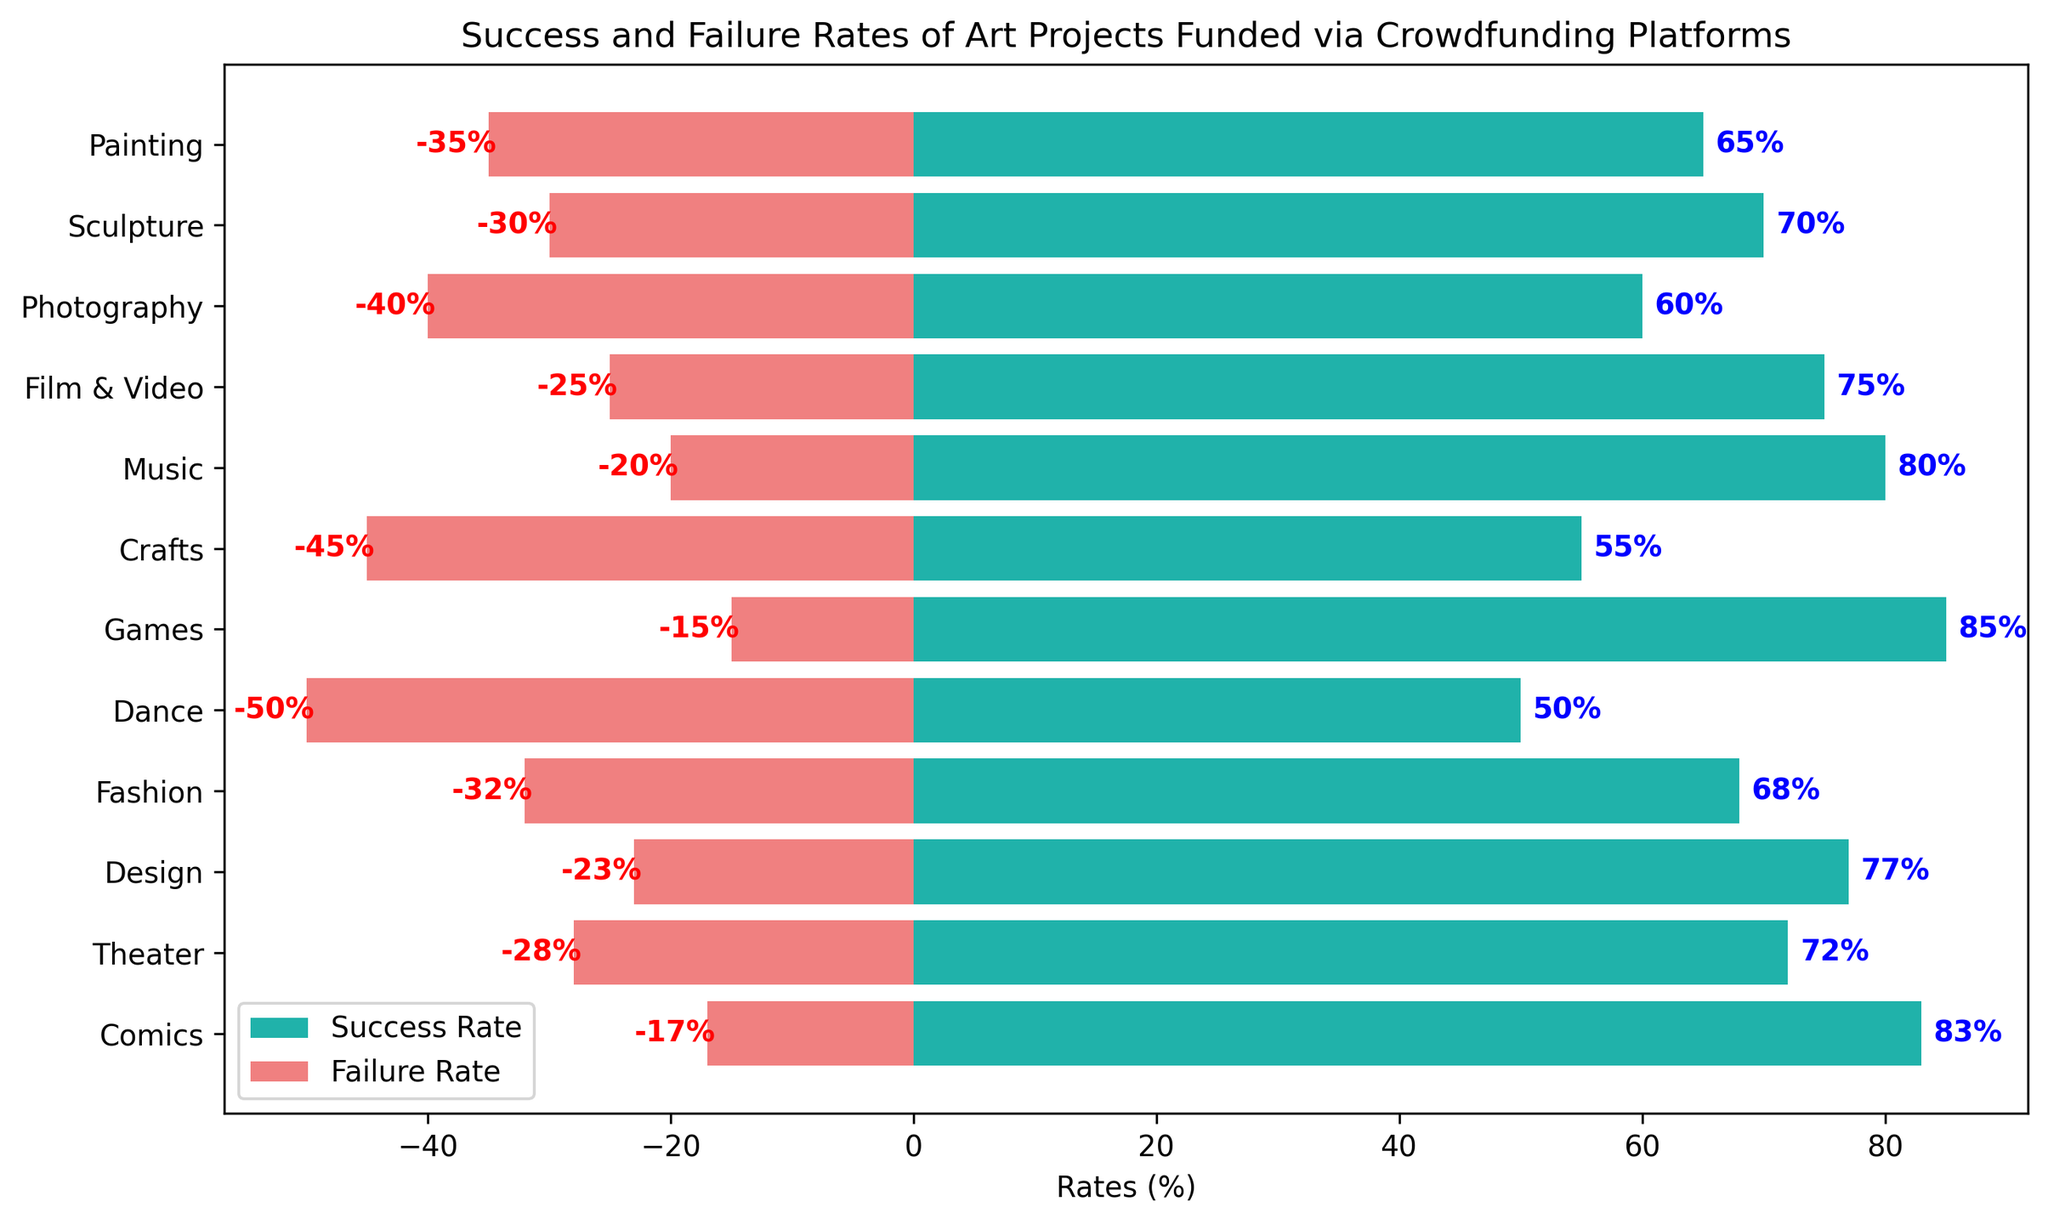What is the success rate for Painting projects? Look at the bar labeled 'Painting' on the y-axis and read the value of the corresponding lightseagreen bar.
Answer: 65% Which project category has the highest failure rate? Locate the longest red bar and check the corresponding category label on the y-axis.
Answer: Dance Compare the success rates between Music and Games projects. Which one is higher and by how much? Identify the lightseagreen bars for Music and Games. Music has 80%, and Games has 85%. Subtract the values: 85% - 80% = 5%.
Answer: Games by 5% What is the combined success rate of Film & Video and Fashion projects? Find the success rates of Film & Video (75%) and Fashion (68%). Add the values together: 75% + 68% = 143%.
Answer: 143% Which two categories have the most similar success rates? Compare the lengths of the lightseagreen bars to find the two that are closest in value. Painting (65%) and Photography (60%) are close, but Design (77%) and Theater (72%) are more similar.
Answer: Design and Theater Are there any project categories with the same failure rate? Check the lengths of the red bars to find any matches. There are no categories with the exact same failure rate.
Answer: No Which project category has the most balanced success and failure rates? Look for the categories with bars that are nearly equal in length but opposite in direction. The 'Dance' category has 50% success and -50% failure, so the total balance is 0%.
Answer: Dance Calculate the average success rate across all project categories. Add all success rates: 65 + 70 + 60 + 75 + 80 + 55 + 85 + 50 + 68 + 77 + 72 + 83. Divide by the number of categories, which is 12. Thus, the average is (65 + 70 + 60 + 75 + 80 + 55 + 85 + 50 + 68 + 77 + 72 + 83) / 12 = 70.42%.
Answer: 70.42% Identify the project category with the lowest success rate and state the percentage. Find the shortest lightseagreen bar and read the corresponding category label on the y-axis. The 'Dance' category has the lowest success rate of 50%.
Answer: Dance with 50% If we consider a project successful if its success rate is above 70%, how many categories fall into this range? Count the categories with lightseagreen bars extending beyond the 70% mark. These are: 'Film & Video' (75%), 'Music' (80%), 'Games' (85%), 'Design' (77%), 'Theater' (72%), and 'Comics' (83%). There are 6 categories in total.
Answer: 6 